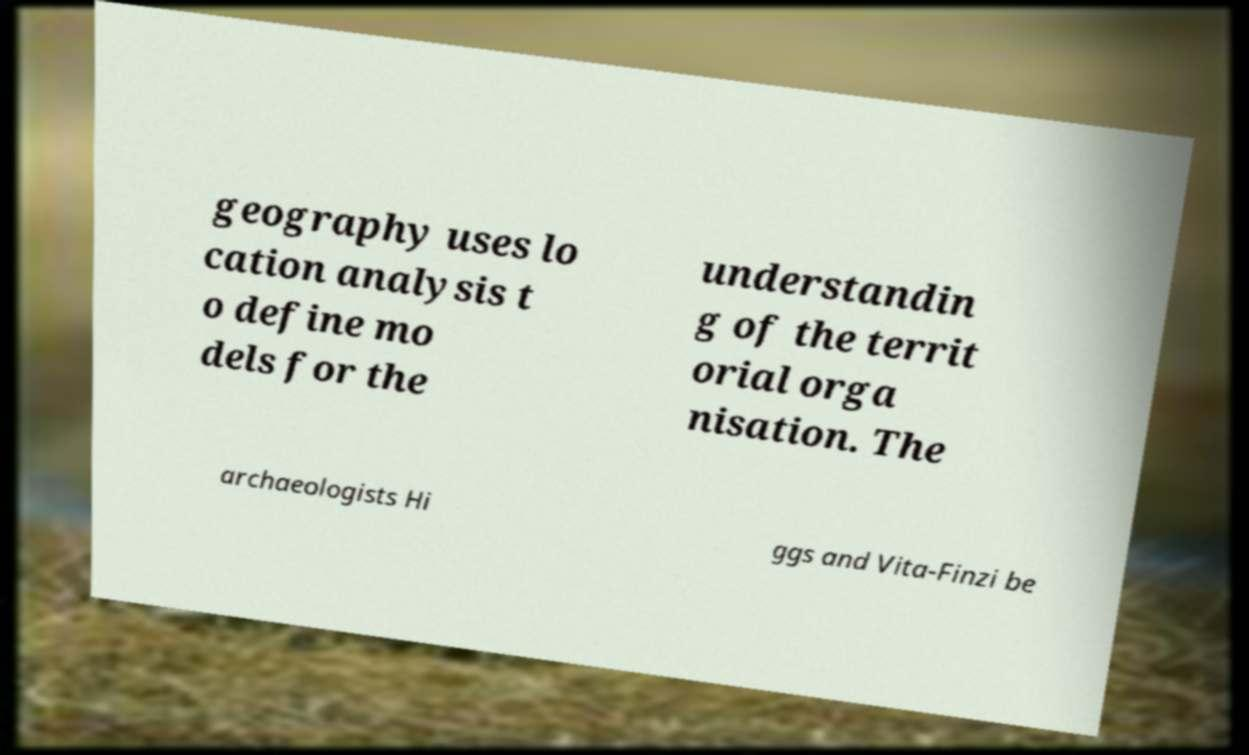For documentation purposes, I need the text within this image transcribed. Could you provide that? geography uses lo cation analysis t o define mo dels for the understandin g of the territ orial orga nisation. The archaeologists Hi ggs and Vita-Finzi be 